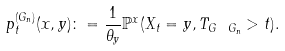<formula> <loc_0><loc_0><loc_500><loc_500>p ^ { ( G _ { n } ) } _ { t } ( x , y ) \colon = \frac { 1 } { \theta _ { y } } \mathbb { P } ^ { x } ( X _ { t } = y , T _ { G \ G _ { n } } > t ) .</formula> 